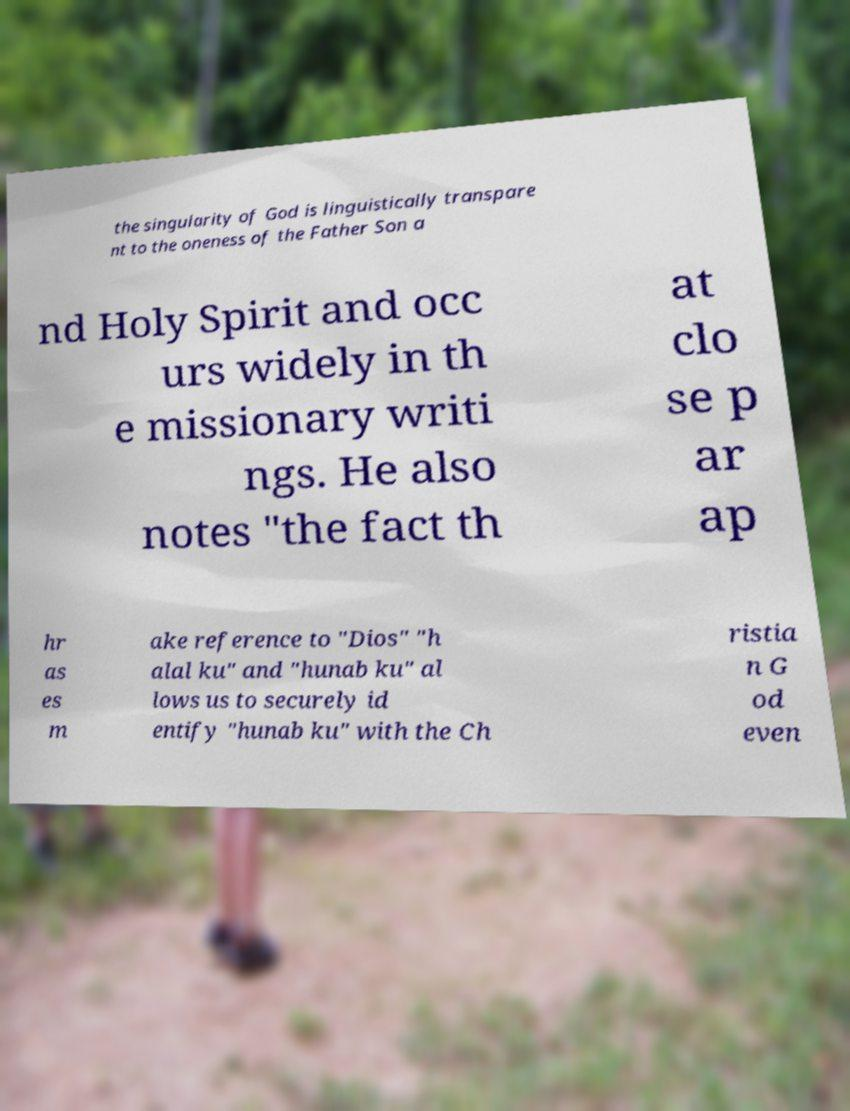Please read and relay the text visible in this image. What does it say? the singularity of God is linguistically transpare nt to the oneness of the Father Son a nd Holy Spirit and occ urs widely in th e missionary writi ngs. He also notes "the fact th at clo se p ar ap hr as es m ake reference to "Dios" "h alal ku" and "hunab ku" al lows us to securely id entify "hunab ku" with the Ch ristia n G od even 